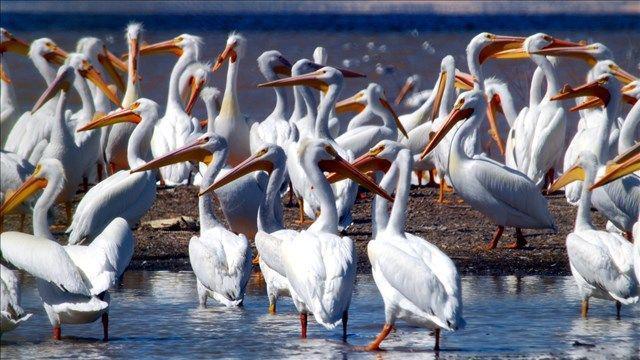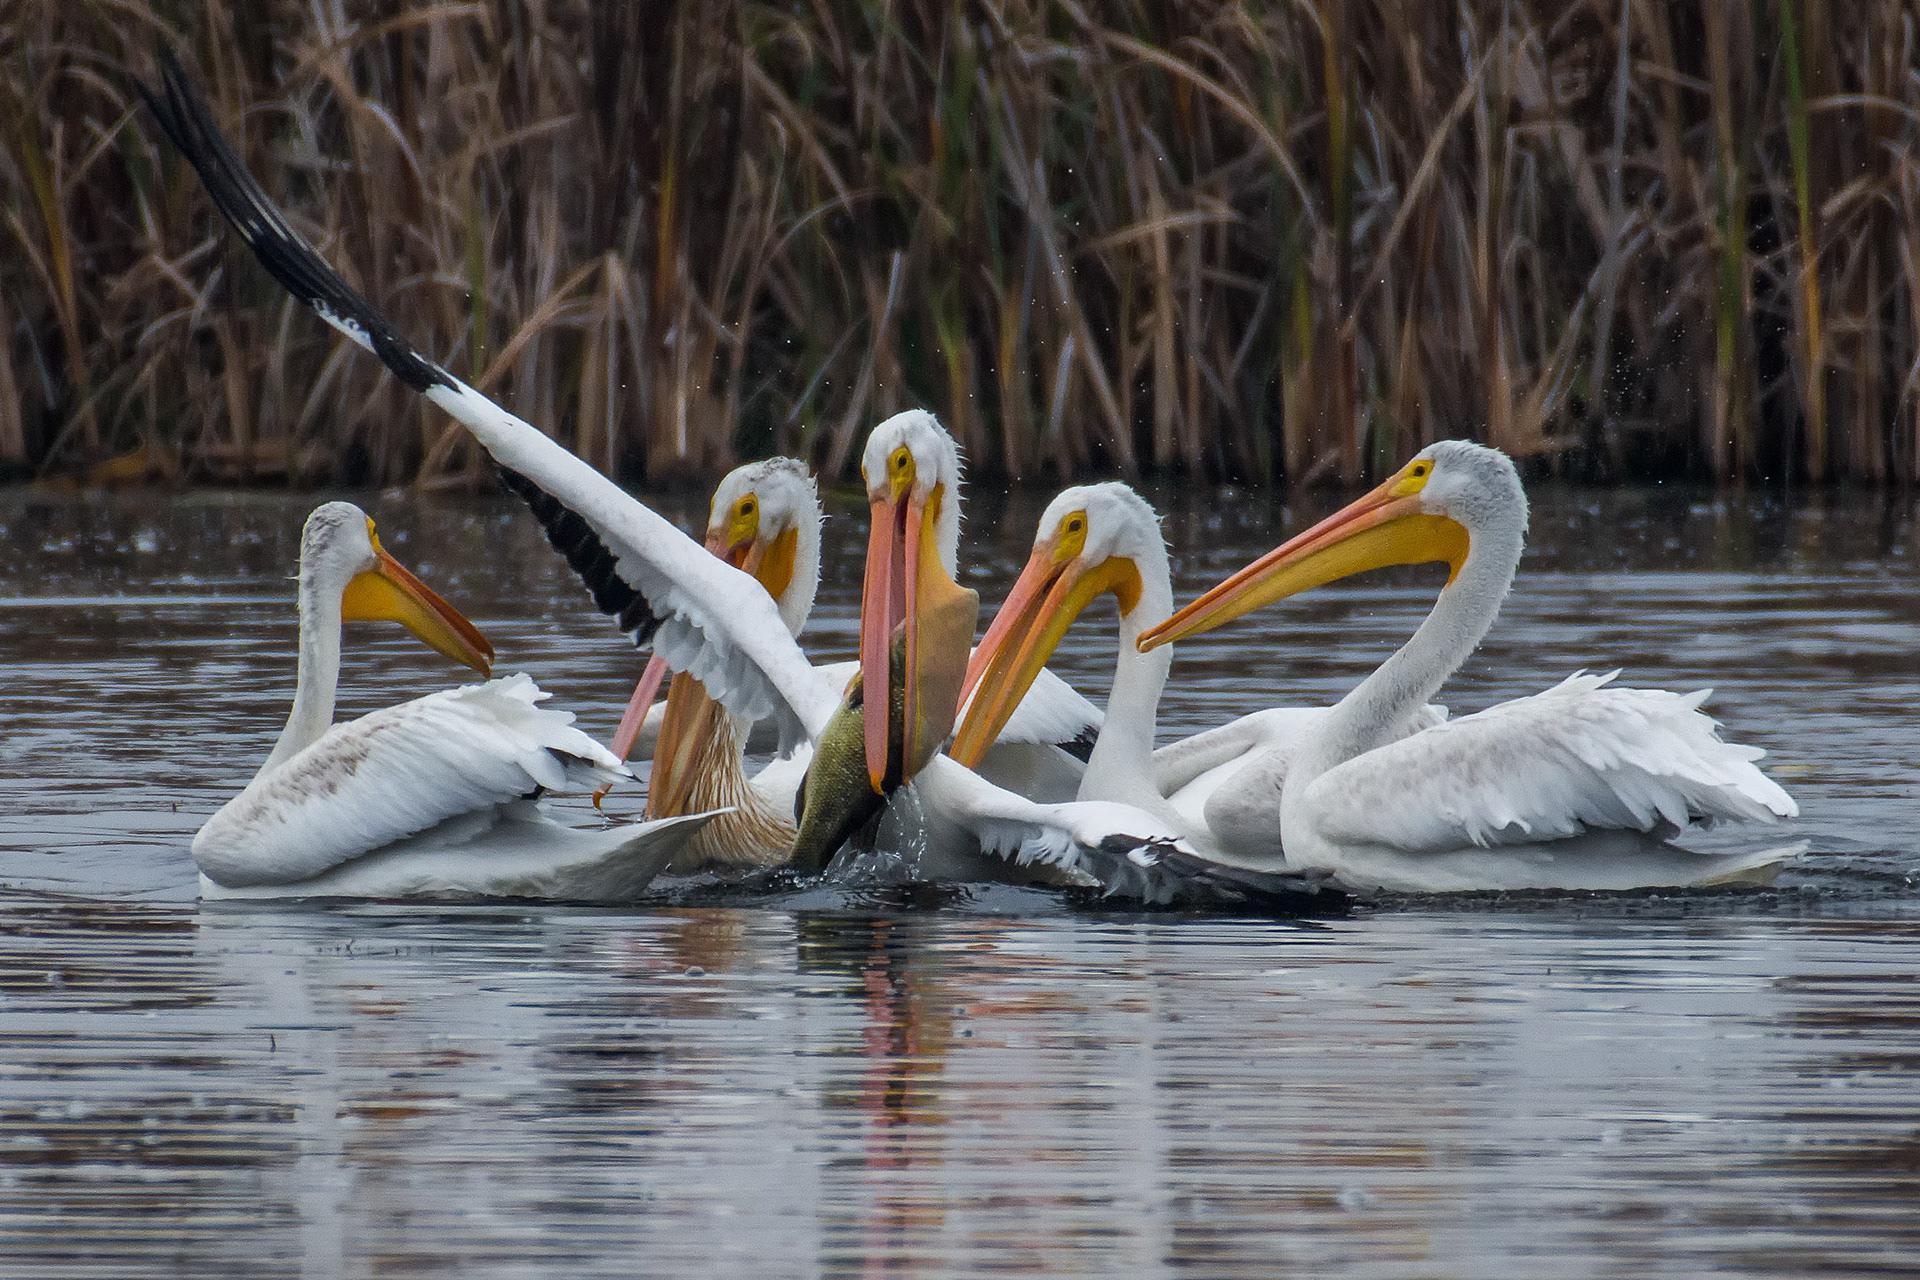The first image is the image on the left, the second image is the image on the right. Given the left and right images, does the statement "At least one bird is sitting in water." hold true? Answer yes or no. Yes. The first image is the image on the left, the second image is the image on the right. Given the left and right images, does the statement "An image shows one white-bodied pelican above blue water, with outstretched wings." hold true? Answer yes or no. No. 